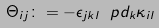Convert formula to latex. <formula><loc_0><loc_0><loc_500><loc_500>\Theta _ { i j } \colon = - \epsilon _ { j k l } \ p d _ { k } \kappa _ { i l }</formula> 